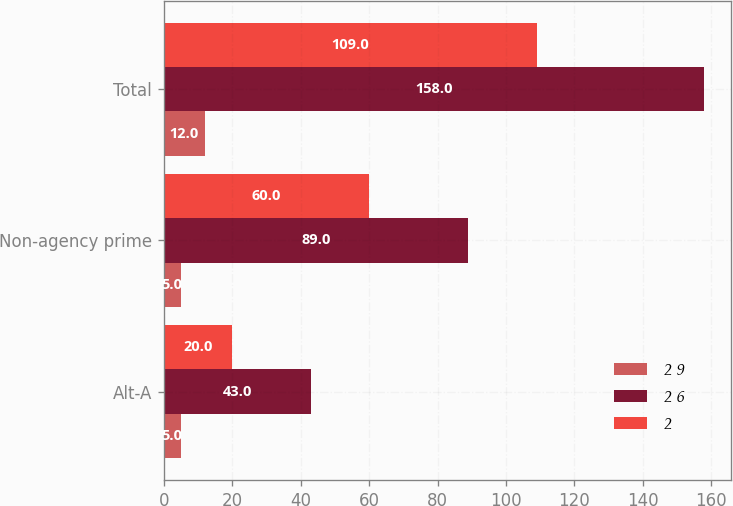Convert chart. <chart><loc_0><loc_0><loc_500><loc_500><stacked_bar_chart><ecel><fcel>Alt-A<fcel>Non-agency prime<fcel>Total<nl><fcel>2 9<fcel>5<fcel>5<fcel>12<nl><fcel>2 6<fcel>43<fcel>89<fcel>158<nl><fcel>2<fcel>20<fcel>60<fcel>109<nl></chart> 